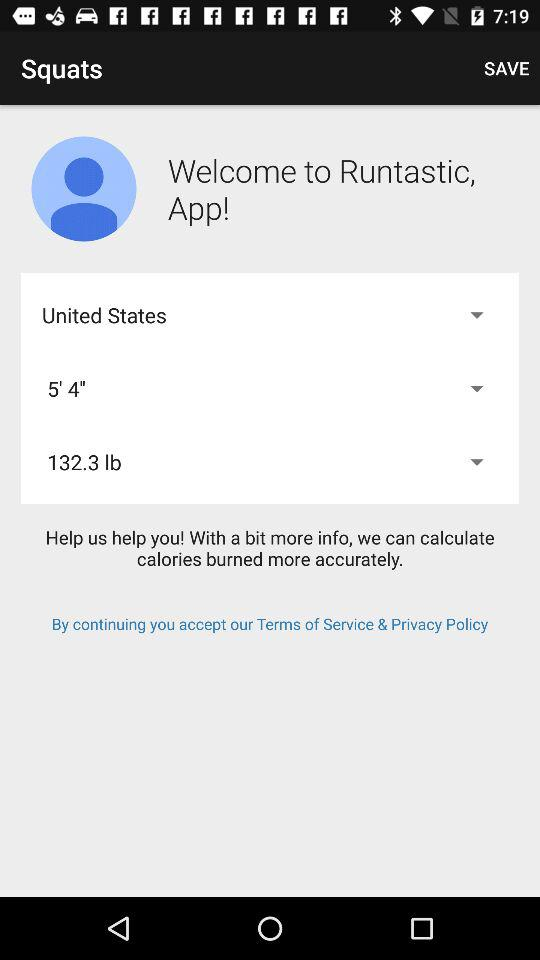Which country is selected? The selected country is the United States. 